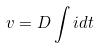<formula> <loc_0><loc_0><loc_500><loc_500>v = D \int i d t</formula> 